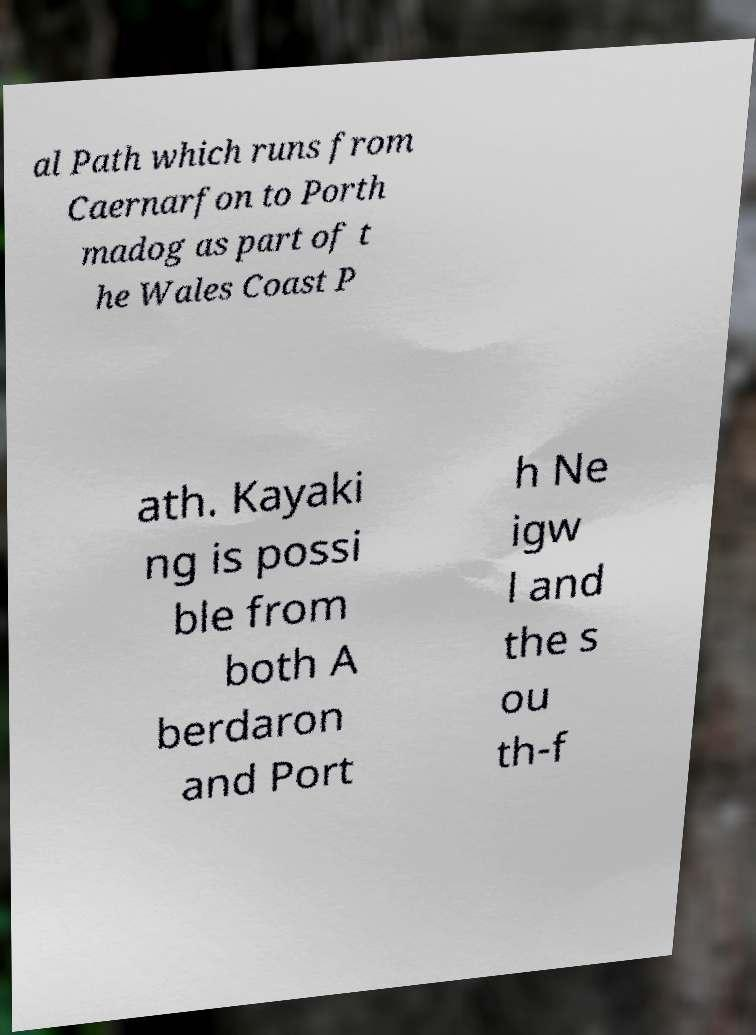Please read and relay the text visible in this image. What does it say? al Path which runs from Caernarfon to Porth madog as part of t he Wales Coast P ath. Kayaki ng is possi ble from both A berdaron and Port h Ne igw l and the s ou th-f 